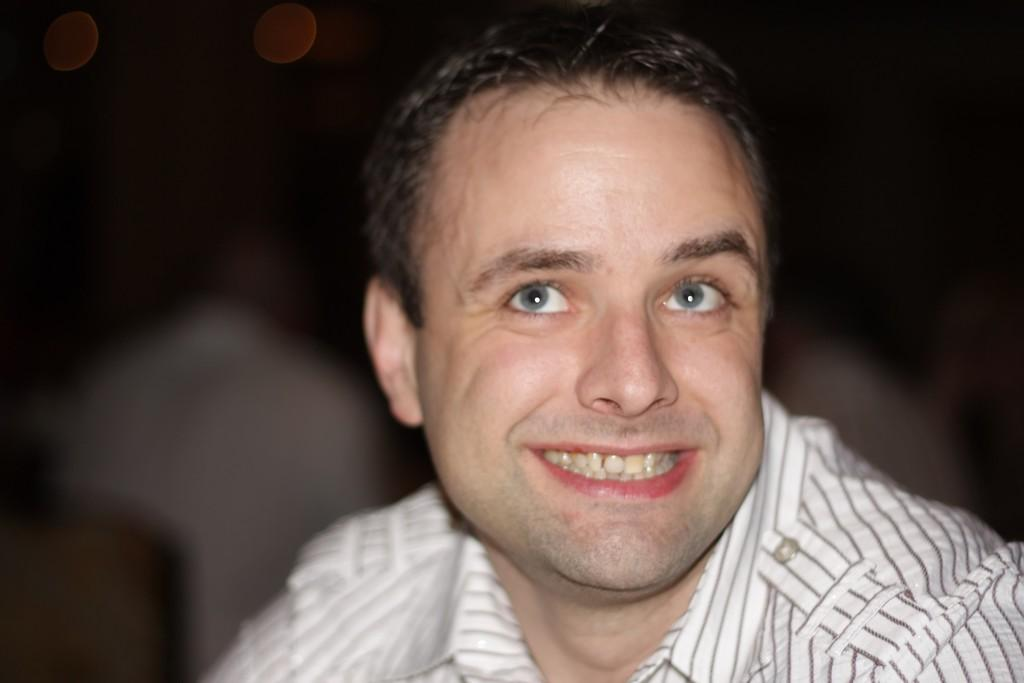What is the main subject in the foreground of the picture? There is a man in the foreground of the picture. What is the man wearing? The man is wearing a white shirt. What expression does the man have on his face? The man has a smile on his face. How would you describe the background of the image? The background of the image is blurred. How many roses can be seen in the man's hand in the image? There are no roses visible in the image, as the man's hands are not shown. What type of rhythm is the man dancing to in the image? There is no indication that the man is dancing in the image, so it is not possible to determine the type of rhythm he might be dancing to. 